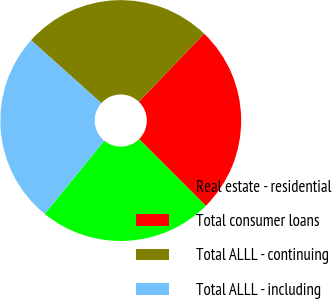Convert chart. <chart><loc_0><loc_0><loc_500><loc_500><pie_chart><fcel>Real estate - residential<fcel>Total consumer loans<fcel>Total ALLL - continuing<fcel>Total ALLL - including<nl><fcel>23.39%<fcel>25.34%<fcel>25.54%<fcel>25.73%<nl></chart> 